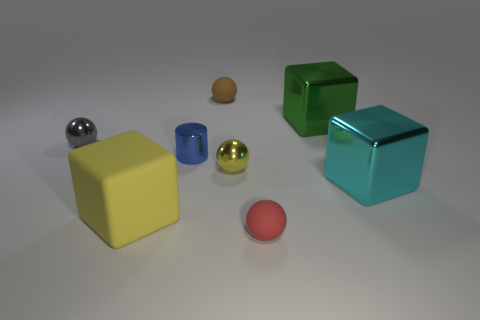What color is the tiny matte object on the left side of the matte sphere that is in front of the yellow metal ball? The tiny matte object located to the left of the matte sphere, which is in front of the yellow metal ball, appears to be brown with a subtle hint of red, similar to the color of terracotta. 